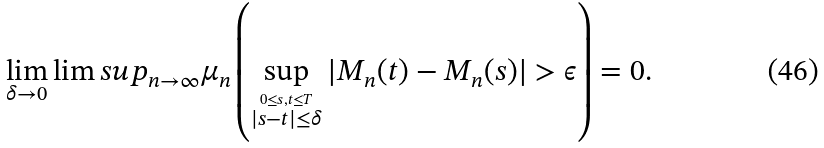Convert formula to latex. <formula><loc_0><loc_0><loc_500><loc_500>\lim _ { \delta \to 0 } \lim s u p _ { n \to \infty } \mu _ { n } \left ( \sup _ { \overset { 0 \leq s , t \leq T } { | s - t | \leq \delta } } | M _ { n } ( t ) - M _ { n } ( s ) | > \epsilon \right ) = 0 .</formula> 